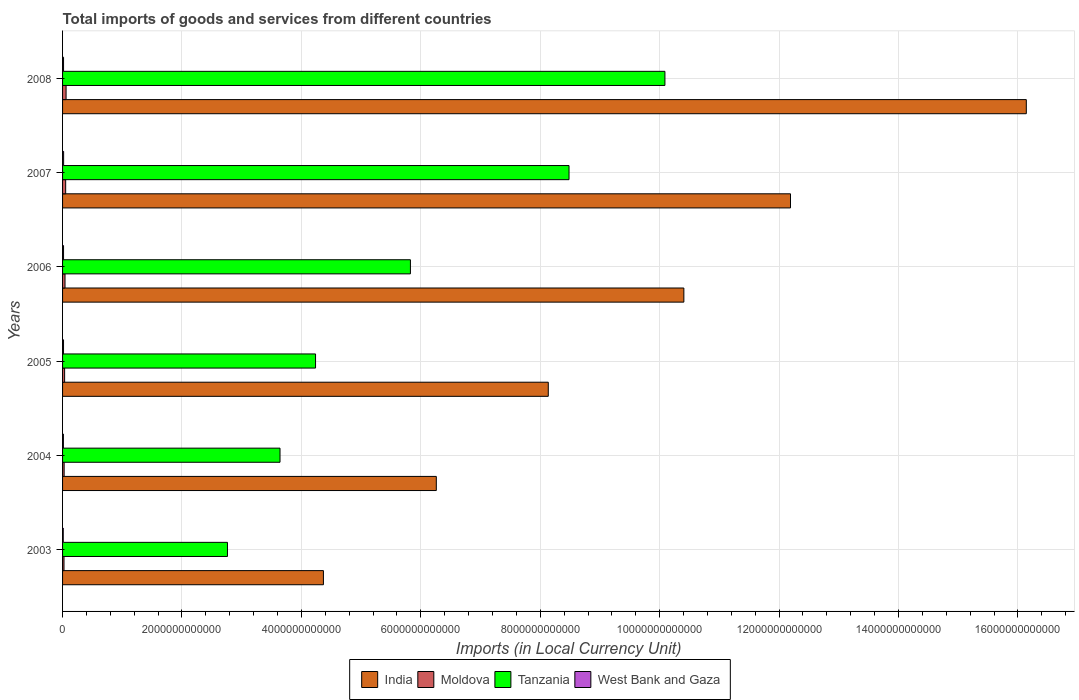How many different coloured bars are there?
Provide a short and direct response. 4. How many groups of bars are there?
Give a very brief answer. 6. Are the number of bars on each tick of the Y-axis equal?
Your answer should be compact. Yes. What is the Amount of goods and services imports in Moldova in 2006?
Provide a short and direct response. 4.11e+1. Across all years, what is the maximum Amount of goods and services imports in Moldova?
Keep it short and to the point. 5.89e+1. Across all years, what is the minimum Amount of goods and services imports in Moldova?
Your response must be concise. 2.41e+1. In which year was the Amount of goods and services imports in West Bank and Gaza maximum?
Offer a very short reply. 2007. What is the total Amount of goods and services imports in Tanzania in the graph?
Provide a short and direct response. 3.50e+13. What is the difference between the Amount of goods and services imports in West Bank and Gaza in 2006 and that in 2008?
Ensure brevity in your answer.  -1.64e+07. What is the difference between the Amount of goods and services imports in India in 2005 and the Amount of goods and services imports in Tanzania in 2003?
Provide a succinct answer. 5.37e+12. What is the average Amount of goods and services imports in Moldova per year?
Make the answer very short. 3.95e+1. In the year 2008, what is the difference between the Amount of goods and services imports in Tanzania and Amount of goods and services imports in Moldova?
Offer a very short reply. 1.00e+13. In how many years, is the Amount of goods and services imports in Moldova greater than 8400000000000 LCU?
Ensure brevity in your answer.  0. What is the ratio of the Amount of goods and services imports in India in 2003 to that in 2006?
Give a very brief answer. 0.42. Is the Amount of goods and services imports in India in 2005 less than that in 2007?
Your answer should be very brief. Yes. Is the difference between the Amount of goods and services imports in Tanzania in 2004 and 2005 greater than the difference between the Amount of goods and services imports in Moldova in 2004 and 2005?
Keep it short and to the point. No. What is the difference between the highest and the second highest Amount of goods and services imports in Moldova?
Offer a terse response. 6.99e+09. What is the difference between the highest and the lowest Amount of goods and services imports in West Bank and Gaza?
Provide a short and direct response. 6.18e+09. Is the sum of the Amount of goods and services imports in Tanzania in 2003 and 2005 greater than the maximum Amount of goods and services imports in Moldova across all years?
Provide a succinct answer. Yes. What does the 3rd bar from the bottom in 2006 represents?
Provide a short and direct response. Tanzania. What is the difference between two consecutive major ticks on the X-axis?
Ensure brevity in your answer.  2.00e+12. Are the values on the major ticks of X-axis written in scientific E-notation?
Provide a succinct answer. No. Does the graph contain any zero values?
Ensure brevity in your answer.  No. Where does the legend appear in the graph?
Give a very brief answer. Bottom center. How many legend labels are there?
Give a very brief answer. 4. How are the legend labels stacked?
Ensure brevity in your answer.  Horizontal. What is the title of the graph?
Ensure brevity in your answer.  Total imports of goods and services from different countries. Does "Tonga" appear as one of the legend labels in the graph?
Keep it short and to the point. No. What is the label or title of the X-axis?
Your answer should be compact. Imports (in Local Currency Unit). What is the label or title of the Y-axis?
Make the answer very short. Years. What is the Imports (in Local Currency Unit) of India in 2003?
Keep it short and to the point. 4.37e+12. What is the Imports (in Local Currency Unit) in Moldova in 2003?
Provide a succinct answer. 2.41e+1. What is the Imports (in Local Currency Unit) of Tanzania in 2003?
Your answer should be compact. 2.76e+12. What is the Imports (in Local Currency Unit) in West Bank and Gaza in 2003?
Give a very brief answer. 1.14e+1. What is the Imports (in Local Currency Unit) of India in 2004?
Give a very brief answer. 6.26e+12. What is the Imports (in Local Currency Unit) in Moldova in 2004?
Keep it short and to the point. 2.63e+1. What is the Imports (in Local Currency Unit) of Tanzania in 2004?
Ensure brevity in your answer.  3.64e+12. What is the Imports (in Local Currency Unit) of West Bank and Gaza in 2004?
Provide a succinct answer. 1.41e+1. What is the Imports (in Local Currency Unit) in India in 2005?
Ensure brevity in your answer.  8.13e+12. What is the Imports (in Local Currency Unit) in Moldova in 2005?
Your answer should be compact. 3.45e+1. What is the Imports (in Local Currency Unit) of Tanzania in 2005?
Provide a short and direct response. 4.24e+12. What is the Imports (in Local Currency Unit) in West Bank and Gaza in 2005?
Make the answer very short. 1.60e+1. What is the Imports (in Local Currency Unit) of India in 2006?
Your answer should be very brief. 1.04e+13. What is the Imports (in Local Currency Unit) in Moldova in 2006?
Provide a short and direct response. 4.11e+1. What is the Imports (in Local Currency Unit) in Tanzania in 2006?
Provide a short and direct response. 5.83e+12. What is the Imports (in Local Currency Unit) in West Bank and Gaza in 2006?
Ensure brevity in your answer.  1.64e+1. What is the Imports (in Local Currency Unit) of India in 2007?
Offer a very short reply. 1.22e+13. What is the Imports (in Local Currency Unit) in Moldova in 2007?
Ensure brevity in your answer.  5.19e+1. What is the Imports (in Local Currency Unit) of Tanzania in 2007?
Offer a very short reply. 8.48e+12. What is the Imports (in Local Currency Unit) of West Bank and Gaza in 2007?
Make the answer very short. 1.76e+1. What is the Imports (in Local Currency Unit) in India in 2008?
Ensure brevity in your answer.  1.61e+13. What is the Imports (in Local Currency Unit) of Moldova in 2008?
Your response must be concise. 5.89e+1. What is the Imports (in Local Currency Unit) in Tanzania in 2008?
Your answer should be compact. 1.01e+13. What is the Imports (in Local Currency Unit) of West Bank and Gaza in 2008?
Keep it short and to the point. 1.64e+1. Across all years, what is the maximum Imports (in Local Currency Unit) in India?
Your response must be concise. 1.61e+13. Across all years, what is the maximum Imports (in Local Currency Unit) of Moldova?
Provide a short and direct response. 5.89e+1. Across all years, what is the maximum Imports (in Local Currency Unit) in Tanzania?
Offer a very short reply. 1.01e+13. Across all years, what is the maximum Imports (in Local Currency Unit) of West Bank and Gaza?
Offer a very short reply. 1.76e+1. Across all years, what is the minimum Imports (in Local Currency Unit) of India?
Provide a succinct answer. 4.37e+12. Across all years, what is the minimum Imports (in Local Currency Unit) of Moldova?
Offer a very short reply. 2.41e+1. Across all years, what is the minimum Imports (in Local Currency Unit) in Tanzania?
Your response must be concise. 2.76e+12. Across all years, what is the minimum Imports (in Local Currency Unit) of West Bank and Gaza?
Provide a short and direct response. 1.14e+1. What is the total Imports (in Local Currency Unit) of India in the graph?
Keep it short and to the point. 5.75e+13. What is the total Imports (in Local Currency Unit) of Moldova in the graph?
Provide a succinct answer. 2.37e+11. What is the total Imports (in Local Currency Unit) of Tanzania in the graph?
Provide a short and direct response. 3.50e+13. What is the total Imports (in Local Currency Unit) of West Bank and Gaza in the graph?
Offer a terse response. 9.20e+1. What is the difference between the Imports (in Local Currency Unit) of India in 2003 and that in 2004?
Your response must be concise. -1.89e+12. What is the difference between the Imports (in Local Currency Unit) of Moldova in 2003 and that in 2004?
Offer a terse response. -2.17e+09. What is the difference between the Imports (in Local Currency Unit) of Tanzania in 2003 and that in 2004?
Your answer should be very brief. -8.80e+11. What is the difference between the Imports (in Local Currency Unit) in West Bank and Gaza in 2003 and that in 2004?
Ensure brevity in your answer.  -2.63e+09. What is the difference between the Imports (in Local Currency Unit) of India in 2003 and that in 2005?
Your response must be concise. -3.77e+12. What is the difference between the Imports (in Local Currency Unit) in Moldova in 2003 and that in 2005?
Ensure brevity in your answer.  -1.04e+1. What is the difference between the Imports (in Local Currency Unit) of Tanzania in 2003 and that in 2005?
Make the answer very short. -1.48e+12. What is the difference between the Imports (in Local Currency Unit) in West Bank and Gaza in 2003 and that in 2005?
Your answer should be compact. -4.62e+09. What is the difference between the Imports (in Local Currency Unit) in India in 2003 and that in 2006?
Offer a very short reply. -6.04e+12. What is the difference between the Imports (in Local Currency Unit) in Moldova in 2003 and that in 2006?
Ensure brevity in your answer.  -1.70e+1. What is the difference between the Imports (in Local Currency Unit) of Tanzania in 2003 and that in 2006?
Your response must be concise. -3.06e+12. What is the difference between the Imports (in Local Currency Unit) in West Bank and Gaza in 2003 and that in 2006?
Provide a succinct answer. -5.00e+09. What is the difference between the Imports (in Local Currency Unit) in India in 2003 and that in 2007?
Your answer should be very brief. -7.82e+12. What is the difference between the Imports (in Local Currency Unit) in Moldova in 2003 and that in 2007?
Your answer should be very brief. -2.78e+1. What is the difference between the Imports (in Local Currency Unit) of Tanzania in 2003 and that in 2007?
Your answer should be very brief. -5.72e+12. What is the difference between the Imports (in Local Currency Unit) of West Bank and Gaza in 2003 and that in 2007?
Your answer should be compact. -6.18e+09. What is the difference between the Imports (in Local Currency Unit) in India in 2003 and that in 2008?
Your answer should be compact. -1.18e+13. What is the difference between the Imports (in Local Currency Unit) of Moldova in 2003 and that in 2008?
Keep it short and to the point. -3.48e+1. What is the difference between the Imports (in Local Currency Unit) of Tanzania in 2003 and that in 2008?
Provide a short and direct response. -7.33e+12. What is the difference between the Imports (in Local Currency Unit) in West Bank and Gaza in 2003 and that in 2008?
Offer a terse response. -5.02e+09. What is the difference between the Imports (in Local Currency Unit) of India in 2004 and that in 2005?
Your answer should be very brief. -1.88e+12. What is the difference between the Imports (in Local Currency Unit) in Moldova in 2004 and that in 2005?
Make the answer very short. -8.25e+09. What is the difference between the Imports (in Local Currency Unit) in Tanzania in 2004 and that in 2005?
Give a very brief answer. -5.95e+11. What is the difference between the Imports (in Local Currency Unit) of West Bank and Gaza in 2004 and that in 2005?
Offer a very short reply. -1.99e+09. What is the difference between the Imports (in Local Currency Unit) in India in 2004 and that in 2006?
Ensure brevity in your answer.  -4.15e+12. What is the difference between the Imports (in Local Currency Unit) of Moldova in 2004 and that in 2006?
Make the answer very short. -1.49e+1. What is the difference between the Imports (in Local Currency Unit) in Tanzania in 2004 and that in 2006?
Provide a succinct answer. -2.18e+12. What is the difference between the Imports (in Local Currency Unit) of West Bank and Gaza in 2004 and that in 2006?
Offer a very short reply. -2.37e+09. What is the difference between the Imports (in Local Currency Unit) in India in 2004 and that in 2007?
Provide a succinct answer. -5.93e+12. What is the difference between the Imports (in Local Currency Unit) in Moldova in 2004 and that in 2007?
Offer a very short reply. -2.56e+1. What is the difference between the Imports (in Local Currency Unit) in Tanzania in 2004 and that in 2007?
Provide a succinct answer. -4.84e+12. What is the difference between the Imports (in Local Currency Unit) in West Bank and Gaza in 2004 and that in 2007?
Your response must be concise. -3.55e+09. What is the difference between the Imports (in Local Currency Unit) in India in 2004 and that in 2008?
Offer a very short reply. -9.88e+12. What is the difference between the Imports (in Local Currency Unit) in Moldova in 2004 and that in 2008?
Provide a short and direct response. -3.26e+1. What is the difference between the Imports (in Local Currency Unit) of Tanzania in 2004 and that in 2008?
Your response must be concise. -6.45e+12. What is the difference between the Imports (in Local Currency Unit) in West Bank and Gaza in 2004 and that in 2008?
Your answer should be compact. -2.39e+09. What is the difference between the Imports (in Local Currency Unit) of India in 2005 and that in 2006?
Your answer should be very brief. -2.27e+12. What is the difference between the Imports (in Local Currency Unit) in Moldova in 2005 and that in 2006?
Your answer should be very brief. -6.61e+09. What is the difference between the Imports (in Local Currency Unit) in Tanzania in 2005 and that in 2006?
Give a very brief answer. -1.59e+12. What is the difference between the Imports (in Local Currency Unit) of West Bank and Gaza in 2005 and that in 2006?
Provide a short and direct response. -3.81e+08. What is the difference between the Imports (in Local Currency Unit) of India in 2005 and that in 2007?
Offer a very short reply. -4.06e+12. What is the difference between the Imports (in Local Currency Unit) in Moldova in 2005 and that in 2007?
Your answer should be very brief. -1.74e+1. What is the difference between the Imports (in Local Currency Unit) of Tanzania in 2005 and that in 2007?
Your answer should be very brief. -4.25e+12. What is the difference between the Imports (in Local Currency Unit) in West Bank and Gaza in 2005 and that in 2007?
Make the answer very short. -1.56e+09. What is the difference between the Imports (in Local Currency Unit) in India in 2005 and that in 2008?
Give a very brief answer. -8.01e+12. What is the difference between the Imports (in Local Currency Unit) in Moldova in 2005 and that in 2008?
Your answer should be very brief. -2.44e+1. What is the difference between the Imports (in Local Currency Unit) of Tanzania in 2005 and that in 2008?
Offer a terse response. -5.85e+12. What is the difference between the Imports (in Local Currency Unit) in West Bank and Gaza in 2005 and that in 2008?
Make the answer very short. -3.98e+08. What is the difference between the Imports (in Local Currency Unit) of India in 2006 and that in 2007?
Offer a very short reply. -1.79e+12. What is the difference between the Imports (in Local Currency Unit) in Moldova in 2006 and that in 2007?
Ensure brevity in your answer.  -1.08e+1. What is the difference between the Imports (in Local Currency Unit) in Tanzania in 2006 and that in 2007?
Give a very brief answer. -2.66e+12. What is the difference between the Imports (in Local Currency Unit) of West Bank and Gaza in 2006 and that in 2007?
Provide a short and direct response. -1.18e+09. What is the difference between the Imports (in Local Currency Unit) of India in 2006 and that in 2008?
Offer a very short reply. -5.74e+12. What is the difference between the Imports (in Local Currency Unit) of Moldova in 2006 and that in 2008?
Ensure brevity in your answer.  -1.78e+1. What is the difference between the Imports (in Local Currency Unit) of Tanzania in 2006 and that in 2008?
Ensure brevity in your answer.  -4.26e+12. What is the difference between the Imports (in Local Currency Unit) of West Bank and Gaza in 2006 and that in 2008?
Provide a succinct answer. -1.64e+07. What is the difference between the Imports (in Local Currency Unit) in India in 2007 and that in 2008?
Offer a very short reply. -3.95e+12. What is the difference between the Imports (in Local Currency Unit) in Moldova in 2007 and that in 2008?
Offer a very short reply. -6.99e+09. What is the difference between the Imports (in Local Currency Unit) of Tanzania in 2007 and that in 2008?
Provide a short and direct response. -1.61e+12. What is the difference between the Imports (in Local Currency Unit) in West Bank and Gaza in 2007 and that in 2008?
Offer a very short reply. 1.16e+09. What is the difference between the Imports (in Local Currency Unit) in India in 2003 and the Imports (in Local Currency Unit) in Moldova in 2004?
Provide a succinct answer. 4.34e+12. What is the difference between the Imports (in Local Currency Unit) of India in 2003 and the Imports (in Local Currency Unit) of Tanzania in 2004?
Your response must be concise. 7.27e+11. What is the difference between the Imports (in Local Currency Unit) in India in 2003 and the Imports (in Local Currency Unit) in West Bank and Gaza in 2004?
Ensure brevity in your answer.  4.35e+12. What is the difference between the Imports (in Local Currency Unit) of Moldova in 2003 and the Imports (in Local Currency Unit) of Tanzania in 2004?
Your answer should be very brief. -3.62e+12. What is the difference between the Imports (in Local Currency Unit) in Moldova in 2003 and the Imports (in Local Currency Unit) in West Bank and Gaza in 2004?
Give a very brief answer. 1.00e+1. What is the difference between the Imports (in Local Currency Unit) of Tanzania in 2003 and the Imports (in Local Currency Unit) of West Bank and Gaza in 2004?
Provide a short and direct response. 2.75e+12. What is the difference between the Imports (in Local Currency Unit) in India in 2003 and the Imports (in Local Currency Unit) in Moldova in 2005?
Your response must be concise. 4.33e+12. What is the difference between the Imports (in Local Currency Unit) in India in 2003 and the Imports (in Local Currency Unit) in Tanzania in 2005?
Offer a very short reply. 1.32e+11. What is the difference between the Imports (in Local Currency Unit) of India in 2003 and the Imports (in Local Currency Unit) of West Bank and Gaza in 2005?
Your response must be concise. 4.35e+12. What is the difference between the Imports (in Local Currency Unit) in Moldova in 2003 and the Imports (in Local Currency Unit) in Tanzania in 2005?
Provide a succinct answer. -4.21e+12. What is the difference between the Imports (in Local Currency Unit) of Moldova in 2003 and the Imports (in Local Currency Unit) of West Bank and Gaza in 2005?
Offer a very short reply. 8.05e+09. What is the difference between the Imports (in Local Currency Unit) in Tanzania in 2003 and the Imports (in Local Currency Unit) in West Bank and Gaza in 2005?
Provide a succinct answer. 2.75e+12. What is the difference between the Imports (in Local Currency Unit) in India in 2003 and the Imports (in Local Currency Unit) in Moldova in 2006?
Offer a very short reply. 4.33e+12. What is the difference between the Imports (in Local Currency Unit) of India in 2003 and the Imports (in Local Currency Unit) of Tanzania in 2006?
Your answer should be very brief. -1.46e+12. What is the difference between the Imports (in Local Currency Unit) of India in 2003 and the Imports (in Local Currency Unit) of West Bank and Gaza in 2006?
Offer a very short reply. 4.35e+12. What is the difference between the Imports (in Local Currency Unit) in Moldova in 2003 and the Imports (in Local Currency Unit) in Tanzania in 2006?
Your response must be concise. -5.80e+12. What is the difference between the Imports (in Local Currency Unit) of Moldova in 2003 and the Imports (in Local Currency Unit) of West Bank and Gaza in 2006?
Your answer should be compact. 7.67e+09. What is the difference between the Imports (in Local Currency Unit) of Tanzania in 2003 and the Imports (in Local Currency Unit) of West Bank and Gaza in 2006?
Keep it short and to the point. 2.75e+12. What is the difference between the Imports (in Local Currency Unit) in India in 2003 and the Imports (in Local Currency Unit) in Moldova in 2007?
Offer a terse response. 4.32e+12. What is the difference between the Imports (in Local Currency Unit) of India in 2003 and the Imports (in Local Currency Unit) of Tanzania in 2007?
Keep it short and to the point. -4.11e+12. What is the difference between the Imports (in Local Currency Unit) in India in 2003 and the Imports (in Local Currency Unit) in West Bank and Gaza in 2007?
Provide a succinct answer. 4.35e+12. What is the difference between the Imports (in Local Currency Unit) in Moldova in 2003 and the Imports (in Local Currency Unit) in Tanzania in 2007?
Offer a terse response. -8.46e+12. What is the difference between the Imports (in Local Currency Unit) of Moldova in 2003 and the Imports (in Local Currency Unit) of West Bank and Gaza in 2007?
Provide a short and direct response. 6.49e+09. What is the difference between the Imports (in Local Currency Unit) in Tanzania in 2003 and the Imports (in Local Currency Unit) in West Bank and Gaza in 2007?
Your response must be concise. 2.74e+12. What is the difference between the Imports (in Local Currency Unit) in India in 2003 and the Imports (in Local Currency Unit) in Moldova in 2008?
Ensure brevity in your answer.  4.31e+12. What is the difference between the Imports (in Local Currency Unit) of India in 2003 and the Imports (in Local Currency Unit) of Tanzania in 2008?
Provide a short and direct response. -5.72e+12. What is the difference between the Imports (in Local Currency Unit) in India in 2003 and the Imports (in Local Currency Unit) in West Bank and Gaza in 2008?
Provide a short and direct response. 4.35e+12. What is the difference between the Imports (in Local Currency Unit) in Moldova in 2003 and the Imports (in Local Currency Unit) in Tanzania in 2008?
Keep it short and to the point. -1.01e+13. What is the difference between the Imports (in Local Currency Unit) in Moldova in 2003 and the Imports (in Local Currency Unit) in West Bank and Gaza in 2008?
Give a very brief answer. 7.65e+09. What is the difference between the Imports (in Local Currency Unit) in Tanzania in 2003 and the Imports (in Local Currency Unit) in West Bank and Gaza in 2008?
Your response must be concise. 2.75e+12. What is the difference between the Imports (in Local Currency Unit) of India in 2004 and the Imports (in Local Currency Unit) of Moldova in 2005?
Offer a very short reply. 6.22e+12. What is the difference between the Imports (in Local Currency Unit) in India in 2004 and the Imports (in Local Currency Unit) in Tanzania in 2005?
Your response must be concise. 2.02e+12. What is the difference between the Imports (in Local Currency Unit) of India in 2004 and the Imports (in Local Currency Unit) of West Bank and Gaza in 2005?
Your response must be concise. 6.24e+12. What is the difference between the Imports (in Local Currency Unit) in Moldova in 2004 and the Imports (in Local Currency Unit) in Tanzania in 2005?
Offer a very short reply. -4.21e+12. What is the difference between the Imports (in Local Currency Unit) in Moldova in 2004 and the Imports (in Local Currency Unit) in West Bank and Gaza in 2005?
Give a very brief answer. 1.02e+1. What is the difference between the Imports (in Local Currency Unit) of Tanzania in 2004 and the Imports (in Local Currency Unit) of West Bank and Gaza in 2005?
Your response must be concise. 3.63e+12. What is the difference between the Imports (in Local Currency Unit) in India in 2004 and the Imports (in Local Currency Unit) in Moldova in 2006?
Provide a succinct answer. 6.22e+12. What is the difference between the Imports (in Local Currency Unit) of India in 2004 and the Imports (in Local Currency Unit) of Tanzania in 2006?
Provide a succinct answer. 4.34e+11. What is the difference between the Imports (in Local Currency Unit) in India in 2004 and the Imports (in Local Currency Unit) in West Bank and Gaza in 2006?
Make the answer very short. 6.24e+12. What is the difference between the Imports (in Local Currency Unit) in Moldova in 2004 and the Imports (in Local Currency Unit) in Tanzania in 2006?
Provide a succinct answer. -5.80e+12. What is the difference between the Imports (in Local Currency Unit) in Moldova in 2004 and the Imports (in Local Currency Unit) in West Bank and Gaza in 2006?
Offer a terse response. 9.84e+09. What is the difference between the Imports (in Local Currency Unit) in Tanzania in 2004 and the Imports (in Local Currency Unit) in West Bank and Gaza in 2006?
Ensure brevity in your answer.  3.63e+12. What is the difference between the Imports (in Local Currency Unit) in India in 2004 and the Imports (in Local Currency Unit) in Moldova in 2007?
Provide a succinct answer. 6.21e+12. What is the difference between the Imports (in Local Currency Unit) of India in 2004 and the Imports (in Local Currency Unit) of Tanzania in 2007?
Ensure brevity in your answer.  -2.22e+12. What is the difference between the Imports (in Local Currency Unit) in India in 2004 and the Imports (in Local Currency Unit) in West Bank and Gaza in 2007?
Offer a terse response. 6.24e+12. What is the difference between the Imports (in Local Currency Unit) of Moldova in 2004 and the Imports (in Local Currency Unit) of Tanzania in 2007?
Provide a short and direct response. -8.46e+12. What is the difference between the Imports (in Local Currency Unit) of Moldova in 2004 and the Imports (in Local Currency Unit) of West Bank and Gaza in 2007?
Keep it short and to the point. 8.66e+09. What is the difference between the Imports (in Local Currency Unit) of Tanzania in 2004 and the Imports (in Local Currency Unit) of West Bank and Gaza in 2007?
Your response must be concise. 3.62e+12. What is the difference between the Imports (in Local Currency Unit) of India in 2004 and the Imports (in Local Currency Unit) of Moldova in 2008?
Your response must be concise. 6.20e+12. What is the difference between the Imports (in Local Currency Unit) of India in 2004 and the Imports (in Local Currency Unit) of Tanzania in 2008?
Your answer should be compact. -3.83e+12. What is the difference between the Imports (in Local Currency Unit) of India in 2004 and the Imports (in Local Currency Unit) of West Bank and Gaza in 2008?
Offer a very short reply. 6.24e+12. What is the difference between the Imports (in Local Currency Unit) of Moldova in 2004 and the Imports (in Local Currency Unit) of Tanzania in 2008?
Your answer should be compact. -1.01e+13. What is the difference between the Imports (in Local Currency Unit) in Moldova in 2004 and the Imports (in Local Currency Unit) in West Bank and Gaza in 2008?
Keep it short and to the point. 9.82e+09. What is the difference between the Imports (in Local Currency Unit) of Tanzania in 2004 and the Imports (in Local Currency Unit) of West Bank and Gaza in 2008?
Your response must be concise. 3.63e+12. What is the difference between the Imports (in Local Currency Unit) in India in 2005 and the Imports (in Local Currency Unit) in Moldova in 2006?
Your response must be concise. 8.09e+12. What is the difference between the Imports (in Local Currency Unit) of India in 2005 and the Imports (in Local Currency Unit) of Tanzania in 2006?
Keep it short and to the point. 2.31e+12. What is the difference between the Imports (in Local Currency Unit) in India in 2005 and the Imports (in Local Currency Unit) in West Bank and Gaza in 2006?
Offer a terse response. 8.12e+12. What is the difference between the Imports (in Local Currency Unit) of Moldova in 2005 and the Imports (in Local Currency Unit) of Tanzania in 2006?
Offer a terse response. -5.79e+12. What is the difference between the Imports (in Local Currency Unit) of Moldova in 2005 and the Imports (in Local Currency Unit) of West Bank and Gaza in 2006?
Give a very brief answer. 1.81e+1. What is the difference between the Imports (in Local Currency Unit) of Tanzania in 2005 and the Imports (in Local Currency Unit) of West Bank and Gaza in 2006?
Make the answer very short. 4.22e+12. What is the difference between the Imports (in Local Currency Unit) of India in 2005 and the Imports (in Local Currency Unit) of Moldova in 2007?
Offer a very short reply. 8.08e+12. What is the difference between the Imports (in Local Currency Unit) in India in 2005 and the Imports (in Local Currency Unit) in Tanzania in 2007?
Your response must be concise. -3.47e+11. What is the difference between the Imports (in Local Currency Unit) in India in 2005 and the Imports (in Local Currency Unit) in West Bank and Gaza in 2007?
Provide a short and direct response. 8.12e+12. What is the difference between the Imports (in Local Currency Unit) in Moldova in 2005 and the Imports (in Local Currency Unit) in Tanzania in 2007?
Provide a short and direct response. -8.45e+12. What is the difference between the Imports (in Local Currency Unit) in Moldova in 2005 and the Imports (in Local Currency Unit) in West Bank and Gaza in 2007?
Provide a succinct answer. 1.69e+1. What is the difference between the Imports (in Local Currency Unit) in Tanzania in 2005 and the Imports (in Local Currency Unit) in West Bank and Gaza in 2007?
Offer a terse response. 4.22e+12. What is the difference between the Imports (in Local Currency Unit) of India in 2005 and the Imports (in Local Currency Unit) of Moldova in 2008?
Your answer should be compact. 8.08e+12. What is the difference between the Imports (in Local Currency Unit) in India in 2005 and the Imports (in Local Currency Unit) in Tanzania in 2008?
Make the answer very short. -1.95e+12. What is the difference between the Imports (in Local Currency Unit) of India in 2005 and the Imports (in Local Currency Unit) of West Bank and Gaza in 2008?
Provide a short and direct response. 8.12e+12. What is the difference between the Imports (in Local Currency Unit) in Moldova in 2005 and the Imports (in Local Currency Unit) in Tanzania in 2008?
Your answer should be compact. -1.01e+13. What is the difference between the Imports (in Local Currency Unit) in Moldova in 2005 and the Imports (in Local Currency Unit) in West Bank and Gaza in 2008?
Your response must be concise. 1.81e+1. What is the difference between the Imports (in Local Currency Unit) in Tanzania in 2005 and the Imports (in Local Currency Unit) in West Bank and Gaza in 2008?
Keep it short and to the point. 4.22e+12. What is the difference between the Imports (in Local Currency Unit) in India in 2006 and the Imports (in Local Currency Unit) in Moldova in 2007?
Offer a very short reply. 1.04e+13. What is the difference between the Imports (in Local Currency Unit) of India in 2006 and the Imports (in Local Currency Unit) of Tanzania in 2007?
Provide a short and direct response. 1.92e+12. What is the difference between the Imports (in Local Currency Unit) of India in 2006 and the Imports (in Local Currency Unit) of West Bank and Gaza in 2007?
Keep it short and to the point. 1.04e+13. What is the difference between the Imports (in Local Currency Unit) in Moldova in 2006 and the Imports (in Local Currency Unit) in Tanzania in 2007?
Provide a short and direct response. -8.44e+12. What is the difference between the Imports (in Local Currency Unit) of Moldova in 2006 and the Imports (in Local Currency Unit) of West Bank and Gaza in 2007?
Your answer should be compact. 2.35e+1. What is the difference between the Imports (in Local Currency Unit) in Tanzania in 2006 and the Imports (in Local Currency Unit) in West Bank and Gaza in 2007?
Give a very brief answer. 5.81e+12. What is the difference between the Imports (in Local Currency Unit) of India in 2006 and the Imports (in Local Currency Unit) of Moldova in 2008?
Give a very brief answer. 1.03e+13. What is the difference between the Imports (in Local Currency Unit) in India in 2006 and the Imports (in Local Currency Unit) in Tanzania in 2008?
Keep it short and to the point. 3.17e+11. What is the difference between the Imports (in Local Currency Unit) of India in 2006 and the Imports (in Local Currency Unit) of West Bank and Gaza in 2008?
Provide a succinct answer. 1.04e+13. What is the difference between the Imports (in Local Currency Unit) of Moldova in 2006 and the Imports (in Local Currency Unit) of Tanzania in 2008?
Your response must be concise. -1.00e+13. What is the difference between the Imports (in Local Currency Unit) of Moldova in 2006 and the Imports (in Local Currency Unit) of West Bank and Gaza in 2008?
Your answer should be compact. 2.47e+1. What is the difference between the Imports (in Local Currency Unit) in Tanzania in 2006 and the Imports (in Local Currency Unit) in West Bank and Gaza in 2008?
Your answer should be very brief. 5.81e+12. What is the difference between the Imports (in Local Currency Unit) of India in 2007 and the Imports (in Local Currency Unit) of Moldova in 2008?
Offer a terse response. 1.21e+13. What is the difference between the Imports (in Local Currency Unit) of India in 2007 and the Imports (in Local Currency Unit) of Tanzania in 2008?
Give a very brief answer. 2.10e+12. What is the difference between the Imports (in Local Currency Unit) in India in 2007 and the Imports (in Local Currency Unit) in West Bank and Gaza in 2008?
Your response must be concise. 1.22e+13. What is the difference between the Imports (in Local Currency Unit) in Moldova in 2007 and the Imports (in Local Currency Unit) in Tanzania in 2008?
Offer a terse response. -1.00e+13. What is the difference between the Imports (in Local Currency Unit) in Moldova in 2007 and the Imports (in Local Currency Unit) in West Bank and Gaza in 2008?
Provide a succinct answer. 3.55e+1. What is the difference between the Imports (in Local Currency Unit) in Tanzania in 2007 and the Imports (in Local Currency Unit) in West Bank and Gaza in 2008?
Provide a short and direct response. 8.47e+12. What is the average Imports (in Local Currency Unit) of India per year?
Your response must be concise. 9.58e+12. What is the average Imports (in Local Currency Unit) of Moldova per year?
Your response must be concise. 3.95e+1. What is the average Imports (in Local Currency Unit) in Tanzania per year?
Offer a terse response. 5.84e+12. What is the average Imports (in Local Currency Unit) in West Bank and Gaza per year?
Your answer should be very brief. 1.53e+1. In the year 2003, what is the difference between the Imports (in Local Currency Unit) in India and Imports (in Local Currency Unit) in Moldova?
Ensure brevity in your answer.  4.34e+12. In the year 2003, what is the difference between the Imports (in Local Currency Unit) in India and Imports (in Local Currency Unit) in Tanzania?
Offer a very short reply. 1.61e+12. In the year 2003, what is the difference between the Imports (in Local Currency Unit) of India and Imports (in Local Currency Unit) of West Bank and Gaza?
Offer a terse response. 4.36e+12. In the year 2003, what is the difference between the Imports (in Local Currency Unit) in Moldova and Imports (in Local Currency Unit) in Tanzania?
Ensure brevity in your answer.  -2.74e+12. In the year 2003, what is the difference between the Imports (in Local Currency Unit) of Moldova and Imports (in Local Currency Unit) of West Bank and Gaza?
Make the answer very short. 1.27e+1. In the year 2003, what is the difference between the Imports (in Local Currency Unit) of Tanzania and Imports (in Local Currency Unit) of West Bank and Gaza?
Ensure brevity in your answer.  2.75e+12. In the year 2004, what is the difference between the Imports (in Local Currency Unit) of India and Imports (in Local Currency Unit) of Moldova?
Provide a succinct answer. 6.23e+12. In the year 2004, what is the difference between the Imports (in Local Currency Unit) in India and Imports (in Local Currency Unit) in Tanzania?
Offer a terse response. 2.62e+12. In the year 2004, what is the difference between the Imports (in Local Currency Unit) of India and Imports (in Local Currency Unit) of West Bank and Gaza?
Your answer should be very brief. 6.25e+12. In the year 2004, what is the difference between the Imports (in Local Currency Unit) of Moldova and Imports (in Local Currency Unit) of Tanzania?
Make the answer very short. -3.62e+12. In the year 2004, what is the difference between the Imports (in Local Currency Unit) of Moldova and Imports (in Local Currency Unit) of West Bank and Gaza?
Your answer should be very brief. 1.22e+1. In the year 2004, what is the difference between the Imports (in Local Currency Unit) in Tanzania and Imports (in Local Currency Unit) in West Bank and Gaza?
Give a very brief answer. 3.63e+12. In the year 2005, what is the difference between the Imports (in Local Currency Unit) in India and Imports (in Local Currency Unit) in Moldova?
Offer a very short reply. 8.10e+12. In the year 2005, what is the difference between the Imports (in Local Currency Unit) in India and Imports (in Local Currency Unit) in Tanzania?
Offer a terse response. 3.90e+12. In the year 2005, what is the difference between the Imports (in Local Currency Unit) in India and Imports (in Local Currency Unit) in West Bank and Gaza?
Your answer should be compact. 8.12e+12. In the year 2005, what is the difference between the Imports (in Local Currency Unit) in Moldova and Imports (in Local Currency Unit) in Tanzania?
Provide a succinct answer. -4.20e+12. In the year 2005, what is the difference between the Imports (in Local Currency Unit) in Moldova and Imports (in Local Currency Unit) in West Bank and Gaza?
Provide a succinct answer. 1.85e+1. In the year 2005, what is the difference between the Imports (in Local Currency Unit) in Tanzania and Imports (in Local Currency Unit) in West Bank and Gaza?
Your answer should be compact. 4.22e+12. In the year 2006, what is the difference between the Imports (in Local Currency Unit) of India and Imports (in Local Currency Unit) of Moldova?
Provide a succinct answer. 1.04e+13. In the year 2006, what is the difference between the Imports (in Local Currency Unit) in India and Imports (in Local Currency Unit) in Tanzania?
Offer a very short reply. 4.58e+12. In the year 2006, what is the difference between the Imports (in Local Currency Unit) in India and Imports (in Local Currency Unit) in West Bank and Gaza?
Ensure brevity in your answer.  1.04e+13. In the year 2006, what is the difference between the Imports (in Local Currency Unit) of Moldova and Imports (in Local Currency Unit) of Tanzania?
Make the answer very short. -5.78e+12. In the year 2006, what is the difference between the Imports (in Local Currency Unit) in Moldova and Imports (in Local Currency Unit) in West Bank and Gaza?
Your answer should be very brief. 2.47e+1. In the year 2006, what is the difference between the Imports (in Local Currency Unit) in Tanzania and Imports (in Local Currency Unit) in West Bank and Gaza?
Your response must be concise. 5.81e+12. In the year 2007, what is the difference between the Imports (in Local Currency Unit) in India and Imports (in Local Currency Unit) in Moldova?
Give a very brief answer. 1.21e+13. In the year 2007, what is the difference between the Imports (in Local Currency Unit) of India and Imports (in Local Currency Unit) of Tanzania?
Provide a succinct answer. 3.71e+12. In the year 2007, what is the difference between the Imports (in Local Currency Unit) of India and Imports (in Local Currency Unit) of West Bank and Gaza?
Your answer should be very brief. 1.22e+13. In the year 2007, what is the difference between the Imports (in Local Currency Unit) of Moldova and Imports (in Local Currency Unit) of Tanzania?
Offer a very short reply. -8.43e+12. In the year 2007, what is the difference between the Imports (in Local Currency Unit) in Moldova and Imports (in Local Currency Unit) in West Bank and Gaza?
Provide a succinct answer. 3.43e+1. In the year 2007, what is the difference between the Imports (in Local Currency Unit) of Tanzania and Imports (in Local Currency Unit) of West Bank and Gaza?
Your answer should be compact. 8.46e+12. In the year 2008, what is the difference between the Imports (in Local Currency Unit) of India and Imports (in Local Currency Unit) of Moldova?
Provide a short and direct response. 1.61e+13. In the year 2008, what is the difference between the Imports (in Local Currency Unit) of India and Imports (in Local Currency Unit) of Tanzania?
Your response must be concise. 6.05e+12. In the year 2008, what is the difference between the Imports (in Local Currency Unit) in India and Imports (in Local Currency Unit) in West Bank and Gaza?
Your answer should be very brief. 1.61e+13. In the year 2008, what is the difference between the Imports (in Local Currency Unit) of Moldova and Imports (in Local Currency Unit) of Tanzania?
Your answer should be compact. -1.00e+13. In the year 2008, what is the difference between the Imports (in Local Currency Unit) in Moldova and Imports (in Local Currency Unit) in West Bank and Gaza?
Provide a succinct answer. 4.25e+1. In the year 2008, what is the difference between the Imports (in Local Currency Unit) in Tanzania and Imports (in Local Currency Unit) in West Bank and Gaza?
Your answer should be very brief. 1.01e+13. What is the ratio of the Imports (in Local Currency Unit) of India in 2003 to that in 2004?
Make the answer very short. 0.7. What is the ratio of the Imports (in Local Currency Unit) of Moldova in 2003 to that in 2004?
Make the answer very short. 0.92. What is the ratio of the Imports (in Local Currency Unit) of Tanzania in 2003 to that in 2004?
Offer a very short reply. 0.76. What is the ratio of the Imports (in Local Currency Unit) in West Bank and Gaza in 2003 to that in 2004?
Offer a very short reply. 0.81. What is the ratio of the Imports (in Local Currency Unit) of India in 2003 to that in 2005?
Your response must be concise. 0.54. What is the ratio of the Imports (in Local Currency Unit) of Moldova in 2003 to that in 2005?
Offer a terse response. 0.7. What is the ratio of the Imports (in Local Currency Unit) of Tanzania in 2003 to that in 2005?
Offer a terse response. 0.65. What is the ratio of the Imports (in Local Currency Unit) of West Bank and Gaza in 2003 to that in 2005?
Keep it short and to the point. 0.71. What is the ratio of the Imports (in Local Currency Unit) of India in 2003 to that in 2006?
Ensure brevity in your answer.  0.42. What is the ratio of the Imports (in Local Currency Unit) in Moldova in 2003 to that in 2006?
Offer a very short reply. 0.59. What is the ratio of the Imports (in Local Currency Unit) of Tanzania in 2003 to that in 2006?
Keep it short and to the point. 0.47. What is the ratio of the Imports (in Local Currency Unit) in West Bank and Gaza in 2003 to that in 2006?
Provide a succinct answer. 0.7. What is the ratio of the Imports (in Local Currency Unit) in India in 2003 to that in 2007?
Give a very brief answer. 0.36. What is the ratio of the Imports (in Local Currency Unit) of Moldova in 2003 to that in 2007?
Ensure brevity in your answer.  0.46. What is the ratio of the Imports (in Local Currency Unit) in Tanzania in 2003 to that in 2007?
Make the answer very short. 0.33. What is the ratio of the Imports (in Local Currency Unit) in West Bank and Gaza in 2003 to that in 2007?
Provide a short and direct response. 0.65. What is the ratio of the Imports (in Local Currency Unit) in India in 2003 to that in 2008?
Your response must be concise. 0.27. What is the ratio of the Imports (in Local Currency Unit) in Moldova in 2003 to that in 2008?
Your answer should be very brief. 0.41. What is the ratio of the Imports (in Local Currency Unit) in Tanzania in 2003 to that in 2008?
Give a very brief answer. 0.27. What is the ratio of the Imports (in Local Currency Unit) of West Bank and Gaza in 2003 to that in 2008?
Offer a terse response. 0.69. What is the ratio of the Imports (in Local Currency Unit) of India in 2004 to that in 2005?
Your response must be concise. 0.77. What is the ratio of the Imports (in Local Currency Unit) of Moldova in 2004 to that in 2005?
Offer a very short reply. 0.76. What is the ratio of the Imports (in Local Currency Unit) of Tanzania in 2004 to that in 2005?
Make the answer very short. 0.86. What is the ratio of the Imports (in Local Currency Unit) of West Bank and Gaza in 2004 to that in 2005?
Keep it short and to the point. 0.88. What is the ratio of the Imports (in Local Currency Unit) in India in 2004 to that in 2006?
Keep it short and to the point. 0.6. What is the ratio of the Imports (in Local Currency Unit) in Moldova in 2004 to that in 2006?
Offer a very short reply. 0.64. What is the ratio of the Imports (in Local Currency Unit) of Tanzania in 2004 to that in 2006?
Your answer should be very brief. 0.63. What is the ratio of the Imports (in Local Currency Unit) of West Bank and Gaza in 2004 to that in 2006?
Your response must be concise. 0.86. What is the ratio of the Imports (in Local Currency Unit) of India in 2004 to that in 2007?
Your answer should be compact. 0.51. What is the ratio of the Imports (in Local Currency Unit) of Moldova in 2004 to that in 2007?
Keep it short and to the point. 0.51. What is the ratio of the Imports (in Local Currency Unit) in Tanzania in 2004 to that in 2007?
Ensure brevity in your answer.  0.43. What is the ratio of the Imports (in Local Currency Unit) of West Bank and Gaza in 2004 to that in 2007?
Keep it short and to the point. 0.8. What is the ratio of the Imports (in Local Currency Unit) in India in 2004 to that in 2008?
Offer a terse response. 0.39. What is the ratio of the Imports (in Local Currency Unit) in Moldova in 2004 to that in 2008?
Offer a very short reply. 0.45. What is the ratio of the Imports (in Local Currency Unit) in Tanzania in 2004 to that in 2008?
Keep it short and to the point. 0.36. What is the ratio of the Imports (in Local Currency Unit) in West Bank and Gaza in 2004 to that in 2008?
Provide a short and direct response. 0.85. What is the ratio of the Imports (in Local Currency Unit) of India in 2005 to that in 2006?
Make the answer very short. 0.78. What is the ratio of the Imports (in Local Currency Unit) of Moldova in 2005 to that in 2006?
Offer a terse response. 0.84. What is the ratio of the Imports (in Local Currency Unit) of Tanzania in 2005 to that in 2006?
Offer a very short reply. 0.73. What is the ratio of the Imports (in Local Currency Unit) of West Bank and Gaza in 2005 to that in 2006?
Your answer should be compact. 0.98. What is the ratio of the Imports (in Local Currency Unit) in India in 2005 to that in 2007?
Ensure brevity in your answer.  0.67. What is the ratio of the Imports (in Local Currency Unit) of Moldova in 2005 to that in 2007?
Provide a succinct answer. 0.67. What is the ratio of the Imports (in Local Currency Unit) in Tanzania in 2005 to that in 2007?
Provide a succinct answer. 0.5. What is the ratio of the Imports (in Local Currency Unit) in West Bank and Gaza in 2005 to that in 2007?
Provide a succinct answer. 0.91. What is the ratio of the Imports (in Local Currency Unit) in India in 2005 to that in 2008?
Make the answer very short. 0.5. What is the ratio of the Imports (in Local Currency Unit) of Moldova in 2005 to that in 2008?
Your answer should be compact. 0.59. What is the ratio of the Imports (in Local Currency Unit) in Tanzania in 2005 to that in 2008?
Provide a succinct answer. 0.42. What is the ratio of the Imports (in Local Currency Unit) of West Bank and Gaza in 2005 to that in 2008?
Provide a succinct answer. 0.98. What is the ratio of the Imports (in Local Currency Unit) in India in 2006 to that in 2007?
Your answer should be compact. 0.85. What is the ratio of the Imports (in Local Currency Unit) in Moldova in 2006 to that in 2007?
Ensure brevity in your answer.  0.79. What is the ratio of the Imports (in Local Currency Unit) in Tanzania in 2006 to that in 2007?
Make the answer very short. 0.69. What is the ratio of the Imports (in Local Currency Unit) of West Bank and Gaza in 2006 to that in 2007?
Your response must be concise. 0.93. What is the ratio of the Imports (in Local Currency Unit) of India in 2006 to that in 2008?
Give a very brief answer. 0.64. What is the ratio of the Imports (in Local Currency Unit) in Moldova in 2006 to that in 2008?
Offer a very short reply. 0.7. What is the ratio of the Imports (in Local Currency Unit) in Tanzania in 2006 to that in 2008?
Provide a short and direct response. 0.58. What is the ratio of the Imports (in Local Currency Unit) in West Bank and Gaza in 2006 to that in 2008?
Keep it short and to the point. 1. What is the ratio of the Imports (in Local Currency Unit) of India in 2007 to that in 2008?
Your answer should be very brief. 0.76. What is the ratio of the Imports (in Local Currency Unit) in Moldova in 2007 to that in 2008?
Give a very brief answer. 0.88. What is the ratio of the Imports (in Local Currency Unit) in Tanzania in 2007 to that in 2008?
Ensure brevity in your answer.  0.84. What is the ratio of the Imports (in Local Currency Unit) in West Bank and Gaza in 2007 to that in 2008?
Keep it short and to the point. 1.07. What is the difference between the highest and the second highest Imports (in Local Currency Unit) of India?
Your answer should be compact. 3.95e+12. What is the difference between the highest and the second highest Imports (in Local Currency Unit) of Moldova?
Provide a succinct answer. 6.99e+09. What is the difference between the highest and the second highest Imports (in Local Currency Unit) of Tanzania?
Make the answer very short. 1.61e+12. What is the difference between the highest and the second highest Imports (in Local Currency Unit) of West Bank and Gaza?
Your response must be concise. 1.16e+09. What is the difference between the highest and the lowest Imports (in Local Currency Unit) in India?
Offer a terse response. 1.18e+13. What is the difference between the highest and the lowest Imports (in Local Currency Unit) in Moldova?
Your answer should be compact. 3.48e+1. What is the difference between the highest and the lowest Imports (in Local Currency Unit) in Tanzania?
Make the answer very short. 7.33e+12. What is the difference between the highest and the lowest Imports (in Local Currency Unit) in West Bank and Gaza?
Your response must be concise. 6.18e+09. 